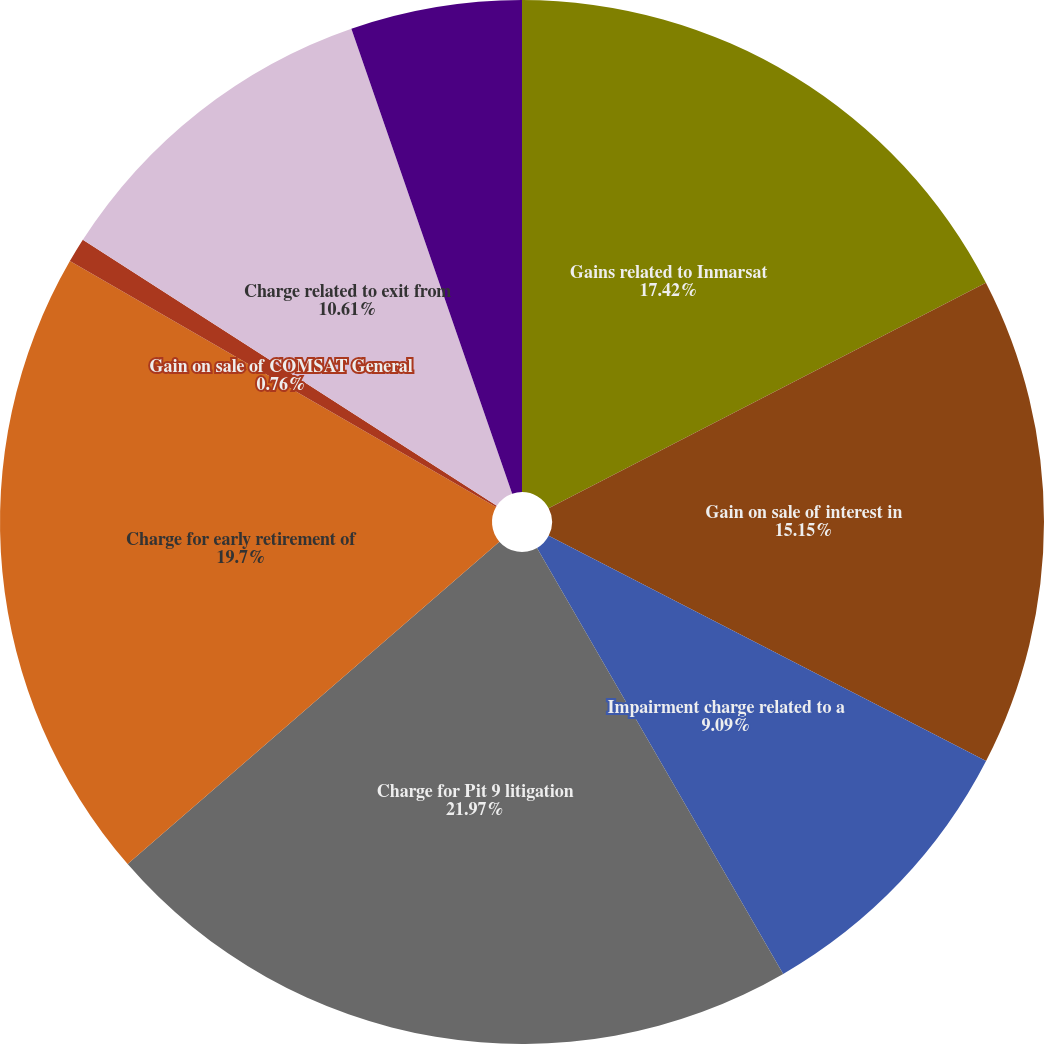Convert chart to OTSL. <chart><loc_0><loc_0><loc_500><loc_500><pie_chart><fcel>Gains related to Inmarsat<fcel>Gain on sale of interest in<fcel>Impairment charge related to a<fcel>Charge for Pit 9 litigation<fcel>Charge for early retirement of<fcel>Gain on sale of COMSAT General<fcel>Charge related to exit from<fcel>Gain on partial reversal of<nl><fcel>17.42%<fcel>15.15%<fcel>9.09%<fcel>21.97%<fcel>19.7%<fcel>0.76%<fcel>10.61%<fcel>5.3%<nl></chart> 